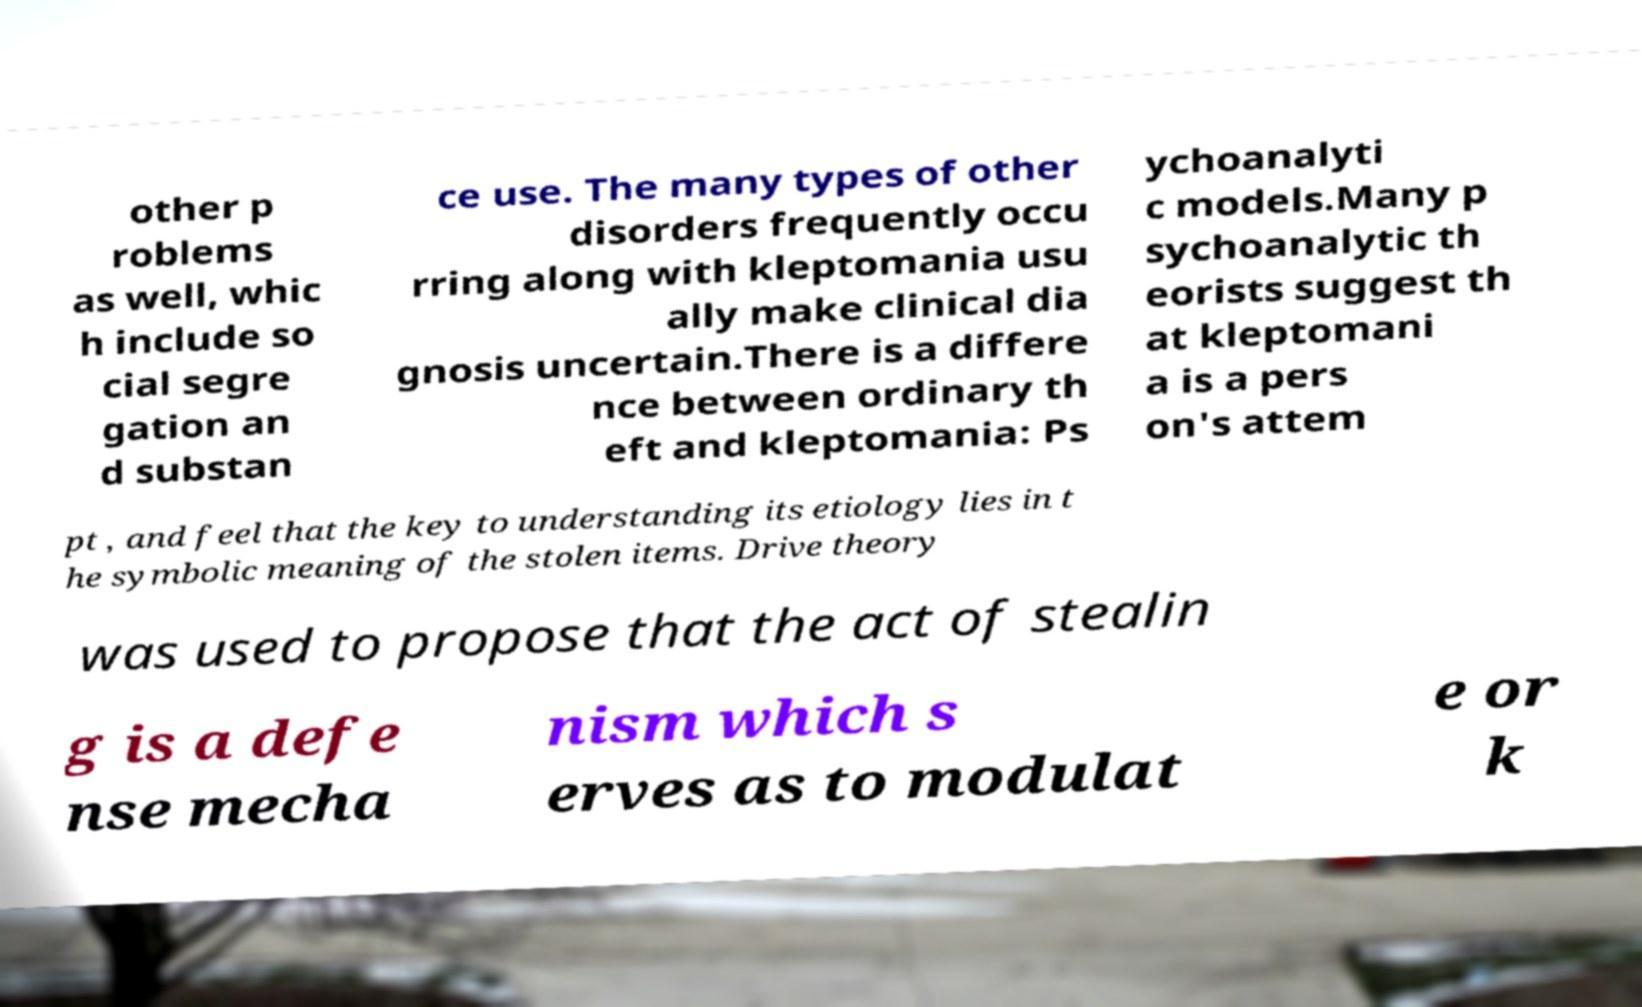Could you extract and type out the text from this image? other p roblems as well, whic h include so cial segre gation an d substan ce use. The many types of other disorders frequently occu rring along with kleptomania usu ally make clinical dia gnosis uncertain.There is a differe nce between ordinary th eft and kleptomania: Ps ychoanalyti c models.Many p sychoanalytic th eorists suggest th at kleptomani a is a pers on's attem pt , and feel that the key to understanding its etiology lies in t he symbolic meaning of the stolen items. Drive theory was used to propose that the act of stealin g is a defe nse mecha nism which s erves as to modulat e or k 